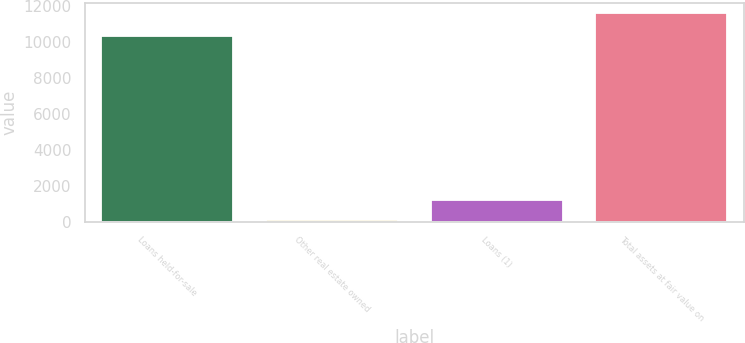<chart> <loc_0><loc_0><loc_500><loc_500><bar_chart><fcel>Loans held-for-sale<fcel>Other real estate owned<fcel>Loans (1)<fcel>Total assets at fair value on<nl><fcel>10326<fcel>107<fcel>1256.9<fcel>11606<nl></chart> 